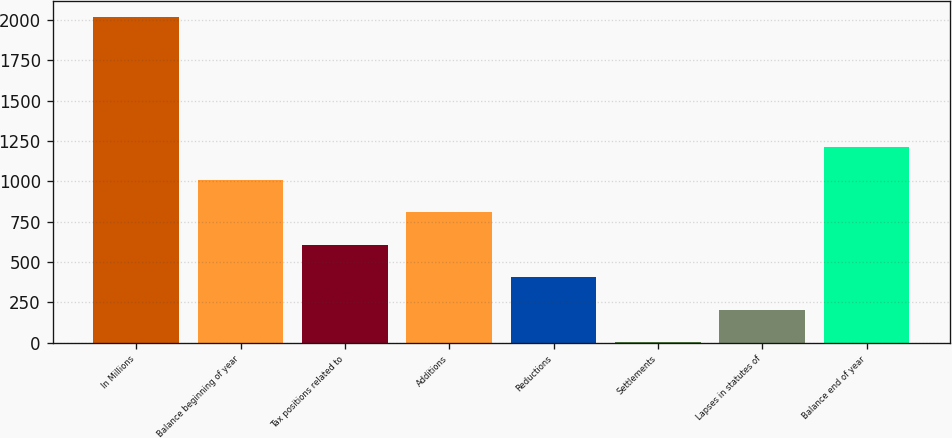<chart> <loc_0><loc_0><loc_500><loc_500><bar_chart><fcel>In Millions<fcel>Balance beginning of year<fcel>Tax positions related to<fcel>Additions<fcel>Reductions<fcel>Settlements<fcel>Lapses in statutes of<fcel>Balance end of year<nl><fcel>2018<fcel>1010.95<fcel>608.13<fcel>809.54<fcel>406.72<fcel>3.9<fcel>205.31<fcel>1212.36<nl></chart> 